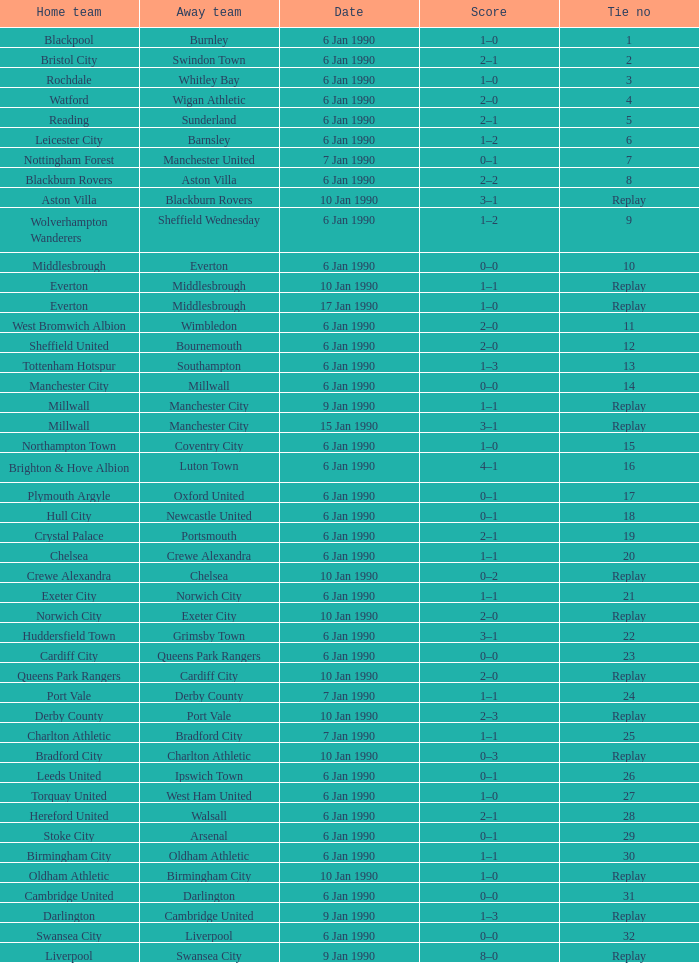What was the score of the game against away team crewe alexandra? 1–1. 